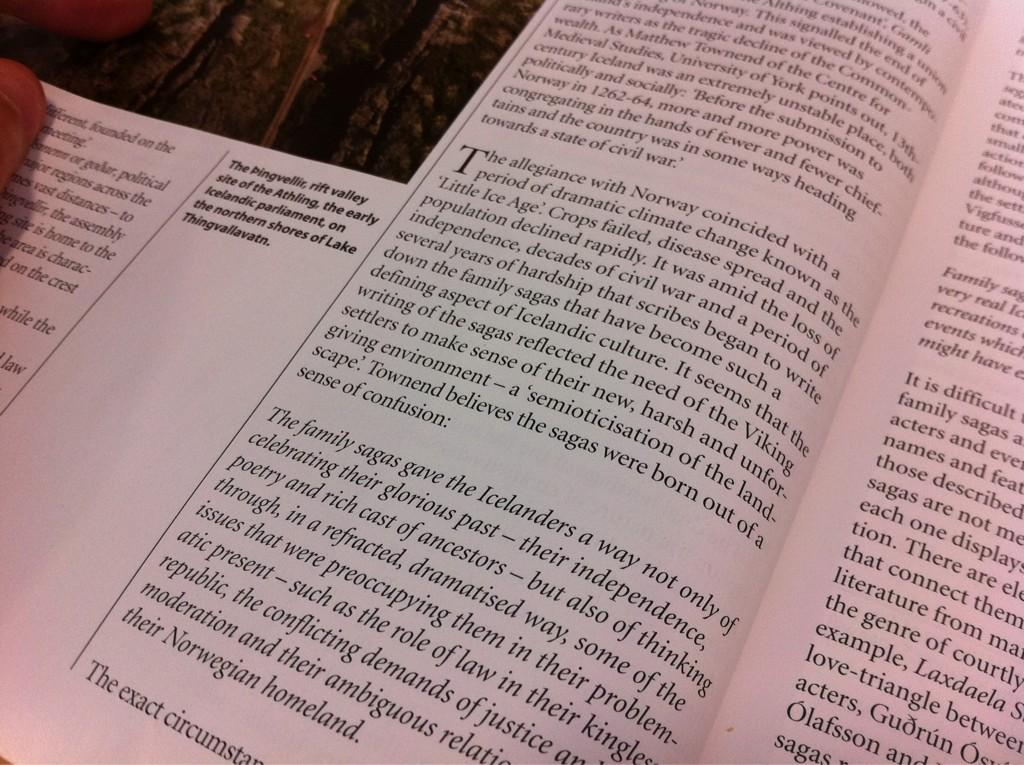<image>
Summarize the visual content of the image. A book that is open and shows information mentioning icelanders on the pages 